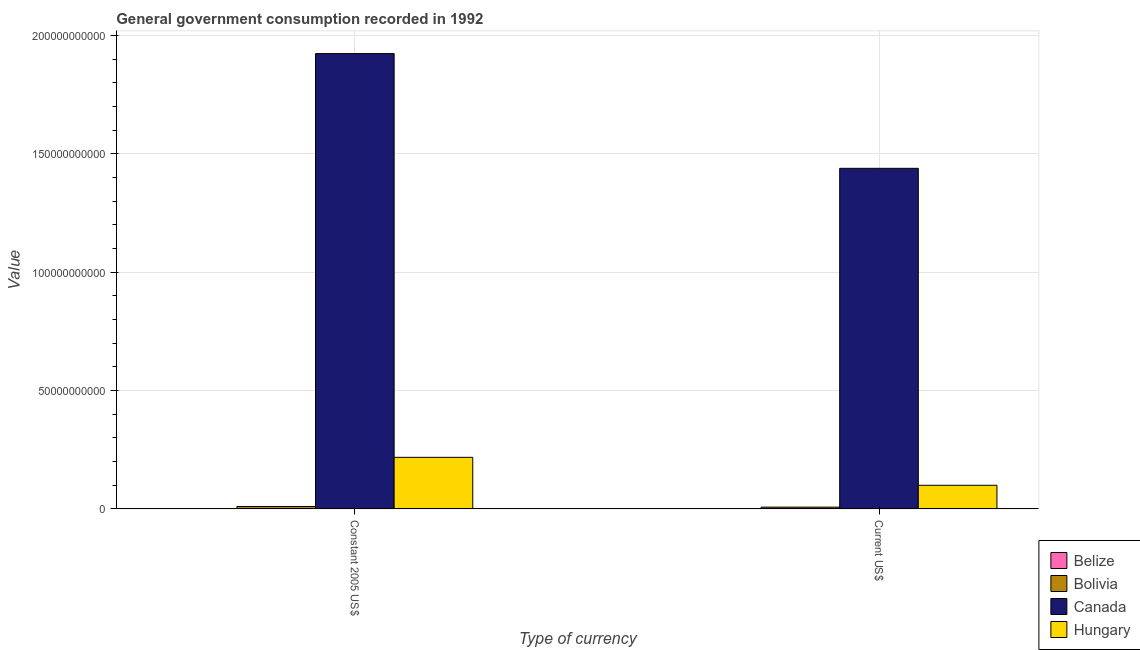Are the number of bars on each tick of the X-axis equal?
Make the answer very short. Yes. How many bars are there on the 1st tick from the left?
Provide a succinct answer. 4. What is the label of the 1st group of bars from the left?
Your answer should be very brief. Constant 2005 US$. What is the value consumed in current us$ in Bolivia?
Make the answer very short. 7.26e+08. Across all countries, what is the maximum value consumed in current us$?
Offer a very short reply. 1.44e+11. Across all countries, what is the minimum value consumed in constant 2005 us$?
Your response must be concise. 9.03e+07. In which country was the value consumed in constant 2005 us$ maximum?
Your response must be concise. Canada. In which country was the value consumed in current us$ minimum?
Your answer should be compact. Belize. What is the total value consumed in current us$ in the graph?
Ensure brevity in your answer.  1.55e+11. What is the difference between the value consumed in constant 2005 us$ in Canada and that in Bolivia?
Your answer should be compact. 1.91e+11. What is the difference between the value consumed in constant 2005 us$ in Canada and the value consumed in current us$ in Bolivia?
Offer a very short reply. 1.92e+11. What is the average value consumed in constant 2005 us$ per country?
Keep it short and to the point. 5.38e+1. What is the difference between the value consumed in constant 2005 us$ and value consumed in current us$ in Hungary?
Give a very brief answer. 1.18e+1. What is the ratio of the value consumed in constant 2005 us$ in Bolivia to that in Belize?
Your response must be concise. 11. What does the 4th bar from the left in Current US$ represents?
Provide a succinct answer. Hungary. What does the 1st bar from the right in Current US$ represents?
Give a very brief answer. Hungary. Are the values on the major ticks of Y-axis written in scientific E-notation?
Ensure brevity in your answer.  No. Does the graph contain any zero values?
Your answer should be compact. No. Does the graph contain grids?
Offer a terse response. Yes. Where does the legend appear in the graph?
Keep it short and to the point. Bottom right. How are the legend labels stacked?
Provide a short and direct response. Vertical. What is the title of the graph?
Ensure brevity in your answer.  General government consumption recorded in 1992. Does "Qatar" appear as one of the legend labels in the graph?
Offer a terse response. No. What is the label or title of the X-axis?
Your answer should be compact. Type of currency. What is the label or title of the Y-axis?
Offer a very short reply. Value. What is the Value in Belize in Constant 2005 US$?
Provide a succinct answer. 9.03e+07. What is the Value of Bolivia in Constant 2005 US$?
Your response must be concise. 9.93e+08. What is the Value in Canada in Constant 2005 US$?
Your answer should be very brief. 1.92e+11. What is the Value of Hungary in Constant 2005 US$?
Provide a short and direct response. 2.18e+1. What is the Value of Belize in Current US$?
Make the answer very short. 7.01e+07. What is the Value of Bolivia in Current US$?
Make the answer very short. 7.26e+08. What is the Value in Canada in Current US$?
Provide a succinct answer. 1.44e+11. What is the Value in Hungary in Current US$?
Keep it short and to the point. 9.96e+09. Across all Type of currency, what is the maximum Value of Belize?
Your answer should be very brief. 9.03e+07. Across all Type of currency, what is the maximum Value of Bolivia?
Make the answer very short. 9.93e+08. Across all Type of currency, what is the maximum Value in Canada?
Ensure brevity in your answer.  1.92e+11. Across all Type of currency, what is the maximum Value of Hungary?
Give a very brief answer. 2.18e+1. Across all Type of currency, what is the minimum Value in Belize?
Make the answer very short. 7.01e+07. Across all Type of currency, what is the minimum Value in Bolivia?
Keep it short and to the point. 7.26e+08. Across all Type of currency, what is the minimum Value in Canada?
Your answer should be very brief. 1.44e+11. Across all Type of currency, what is the minimum Value in Hungary?
Keep it short and to the point. 9.96e+09. What is the total Value of Belize in the graph?
Your response must be concise. 1.60e+08. What is the total Value of Bolivia in the graph?
Your answer should be very brief. 1.72e+09. What is the total Value in Canada in the graph?
Offer a terse response. 3.36e+11. What is the total Value of Hungary in the graph?
Your response must be concise. 3.17e+1. What is the difference between the Value of Belize in Constant 2005 US$ and that in Current US$?
Keep it short and to the point. 2.02e+07. What is the difference between the Value of Bolivia in Constant 2005 US$ and that in Current US$?
Provide a succinct answer. 2.66e+08. What is the difference between the Value of Canada in Constant 2005 US$ and that in Current US$?
Provide a short and direct response. 4.85e+1. What is the difference between the Value in Hungary in Constant 2005 US$ and that in Current US$?
Your answer should be compact. 1.18e+1. What is the difference between the Value of Belize in Constant 2005 US$ and the Value of Bolivia in Current US$?
Offer a very short reply. -6.36e+08. What is the difference between the Value in Belize in Constant 2005 US$ and the Value in Canada in Current US$?
Provide a succinct answer. -1.44e+11. What is the difference between the Value in Belize in Constant 2005 US$ and the Value in Hungary in Current US$?
Your answer should be very brief. -9.87e+09. What is the difference between the Value in Bolivia in Constant 2005 US$ and the Value in Canada in Current US$?
Keep it short and to the point. -1.43e+11. What is the difference between the Value in Bolivia in Constant 2005 US$ and the Value in Hungary in Current US$?
Provide a short and direct response. -8.96e+09. What is the difference between the Value in Canada in Constant 2005 US$ and the Value in Hungary in Current US$?
Offer a very short reply. 1.82e+11. What is the average Value in Belize per Type of currency?
Provide a short and direct response. 8.02e+07. What is the average Value of Bolivia per Type of currency?
Give a very brief answer. 8.60e+08. What is the average Value in Canada per Type of currency?
Keep it short and to the point. 1.68e+11. What is the average Value of Hungary per Type of currency?
Offer a very short reply. 1.59e+1. What is the difference between the Value in Belize and Value in Bolivia in Constant 2005 US$?
Your answer should be compact. -9.02e+08. What is the difference between the Value of Belize and Value of Canada in Constant 2005 US$?
Ensure brevity in your answer.  -1.92e+11. What is the difference between the Value of Belize and Value of Hungary in Constant 2005 US$?
Your answer should be compact. -2.17e+1. What is the difference between the Value in Bolivia and Value in Canada in Constant 2005 US$?
Offer a very short reply. -1.91e+11. What is the difference between the Value of Bolivia and Value of Hungary in Constant 2005 US$?
Give a very brief answer. -2.08e+1. What is the difference between the Value in Canada and Value in Hungary in Constant 2005 US$?
Give a very brief answer. 1.71e+11. What is the difference between the Value in Belize and Value in Bolivia in Current US$?
Provide a short and direct response. -6.56e+08. What is the difference between the Value of Belize and Value of Canada in Current US$?
Provide a succinct answer. -1.44e+11. What is the difference between the Value in Belize and Value in Hungary in Current US$?
Ensure brevity in your answer.  -9.89e+09. What is the difference between the Value of Bolivia and Value of Canada in Current US$?
Make the answer very short. -1.43e+11. What is the difference between the Value of Bolivia and Value of Hungary in Current US$?
Your answer should be compact. -9.23e+09. What is the difference between the Value in Canada and Value in Hungary in Current US$?
Your answer should be very brief. 1.34e+11. What is the ratio of the Value of Belize in Constant 2005 US$ to that in Current US$?
Your response must be concise. 1.29. What is the ratio of the Value of Bolivia in Constant 2005 US$ to that in Current US$?
Your response must be concise. 1.37. What is the ratio of the Value in Canada in Constant 2005 US$ to that in Current US$?
Your answer should be compact. 1.34. What is the ratio of the Value in Hungary in Constant 2005 US$ to that in Current US$?
Offer a very short reply. 2.19. What is the difference between the highest and the second highest Value of Belize?
Provide a short and direct response. 2.02e+07. What is the difference between the highest and the second highest Value of Bolivia?
Your answer should be compact. 2.66e+08. What is the difference between the highest and the second highest Value in Canada?
Your answer should be compact. 4.85e+1. What is the difference between the highest and the second highest Value in Hungary?
Offer a terse response. 1.18e+1. What is the difference between the highest and the lowest Value of Belize?
Provide a succinct answer. 2.02e+07. What is the difference between the highest and the lowest Value of Bolivia?
Offer a very short reply. 2.66e+08. What is the difference between the highest and the lowest Value of Canada?
Your answer should be compact. 4.85e+1. What is the difference between the highest and the lowest Value of Hungary?
Keep it short and to the point. 1.18e+1. 